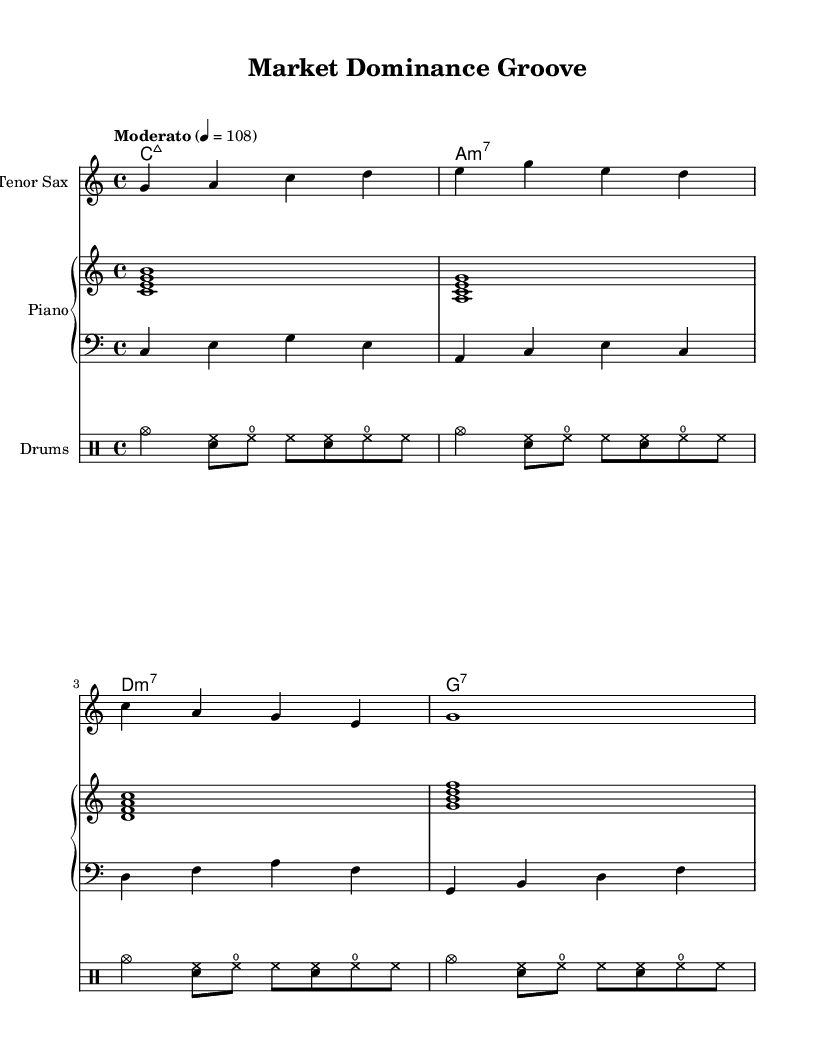What is the key signature of this music? The key signature is indicated at the beginning of the staff and shows C major, which has no sharps or flats.
Answer: C major What is the time signature of this music? The time signature can be found at the beginning of the staff indicated as 4/4, meaning there are four beats in a measure and the quarter note gets one beat.
Answer: 4/4 What is the tempo marking for this piece? The tempo marking is specified at the beginning and states "Moderato" with a metronome marking of 108, indicating a moderate speed.
Answer: Moderato How many measures does the saxophone melody contain? By counting the individual segments divided by the vertical lines, there are 4 measures in the saxophone melody.
Answer: 4 What chord follows A minor 7 in the chord progression? The chord progression is listed in the score and proceeds from A minor 7 to D minor 7 as the next chord in the sequence.
Answer: D minor 7 Which instrument plays the bass line in this piece? The bass line is notated in the score with the clef indicating it is played by the bass instrument, which is specifically shown as a bass staff.
Answer: Bass What type of music is represented in this sheet? The composition reflects characteristics typical of modern instrumental jazz, incorporating syncopated rhythms, improvisational melodies, and extended chords.
Answer: Modern instrumental jazz 